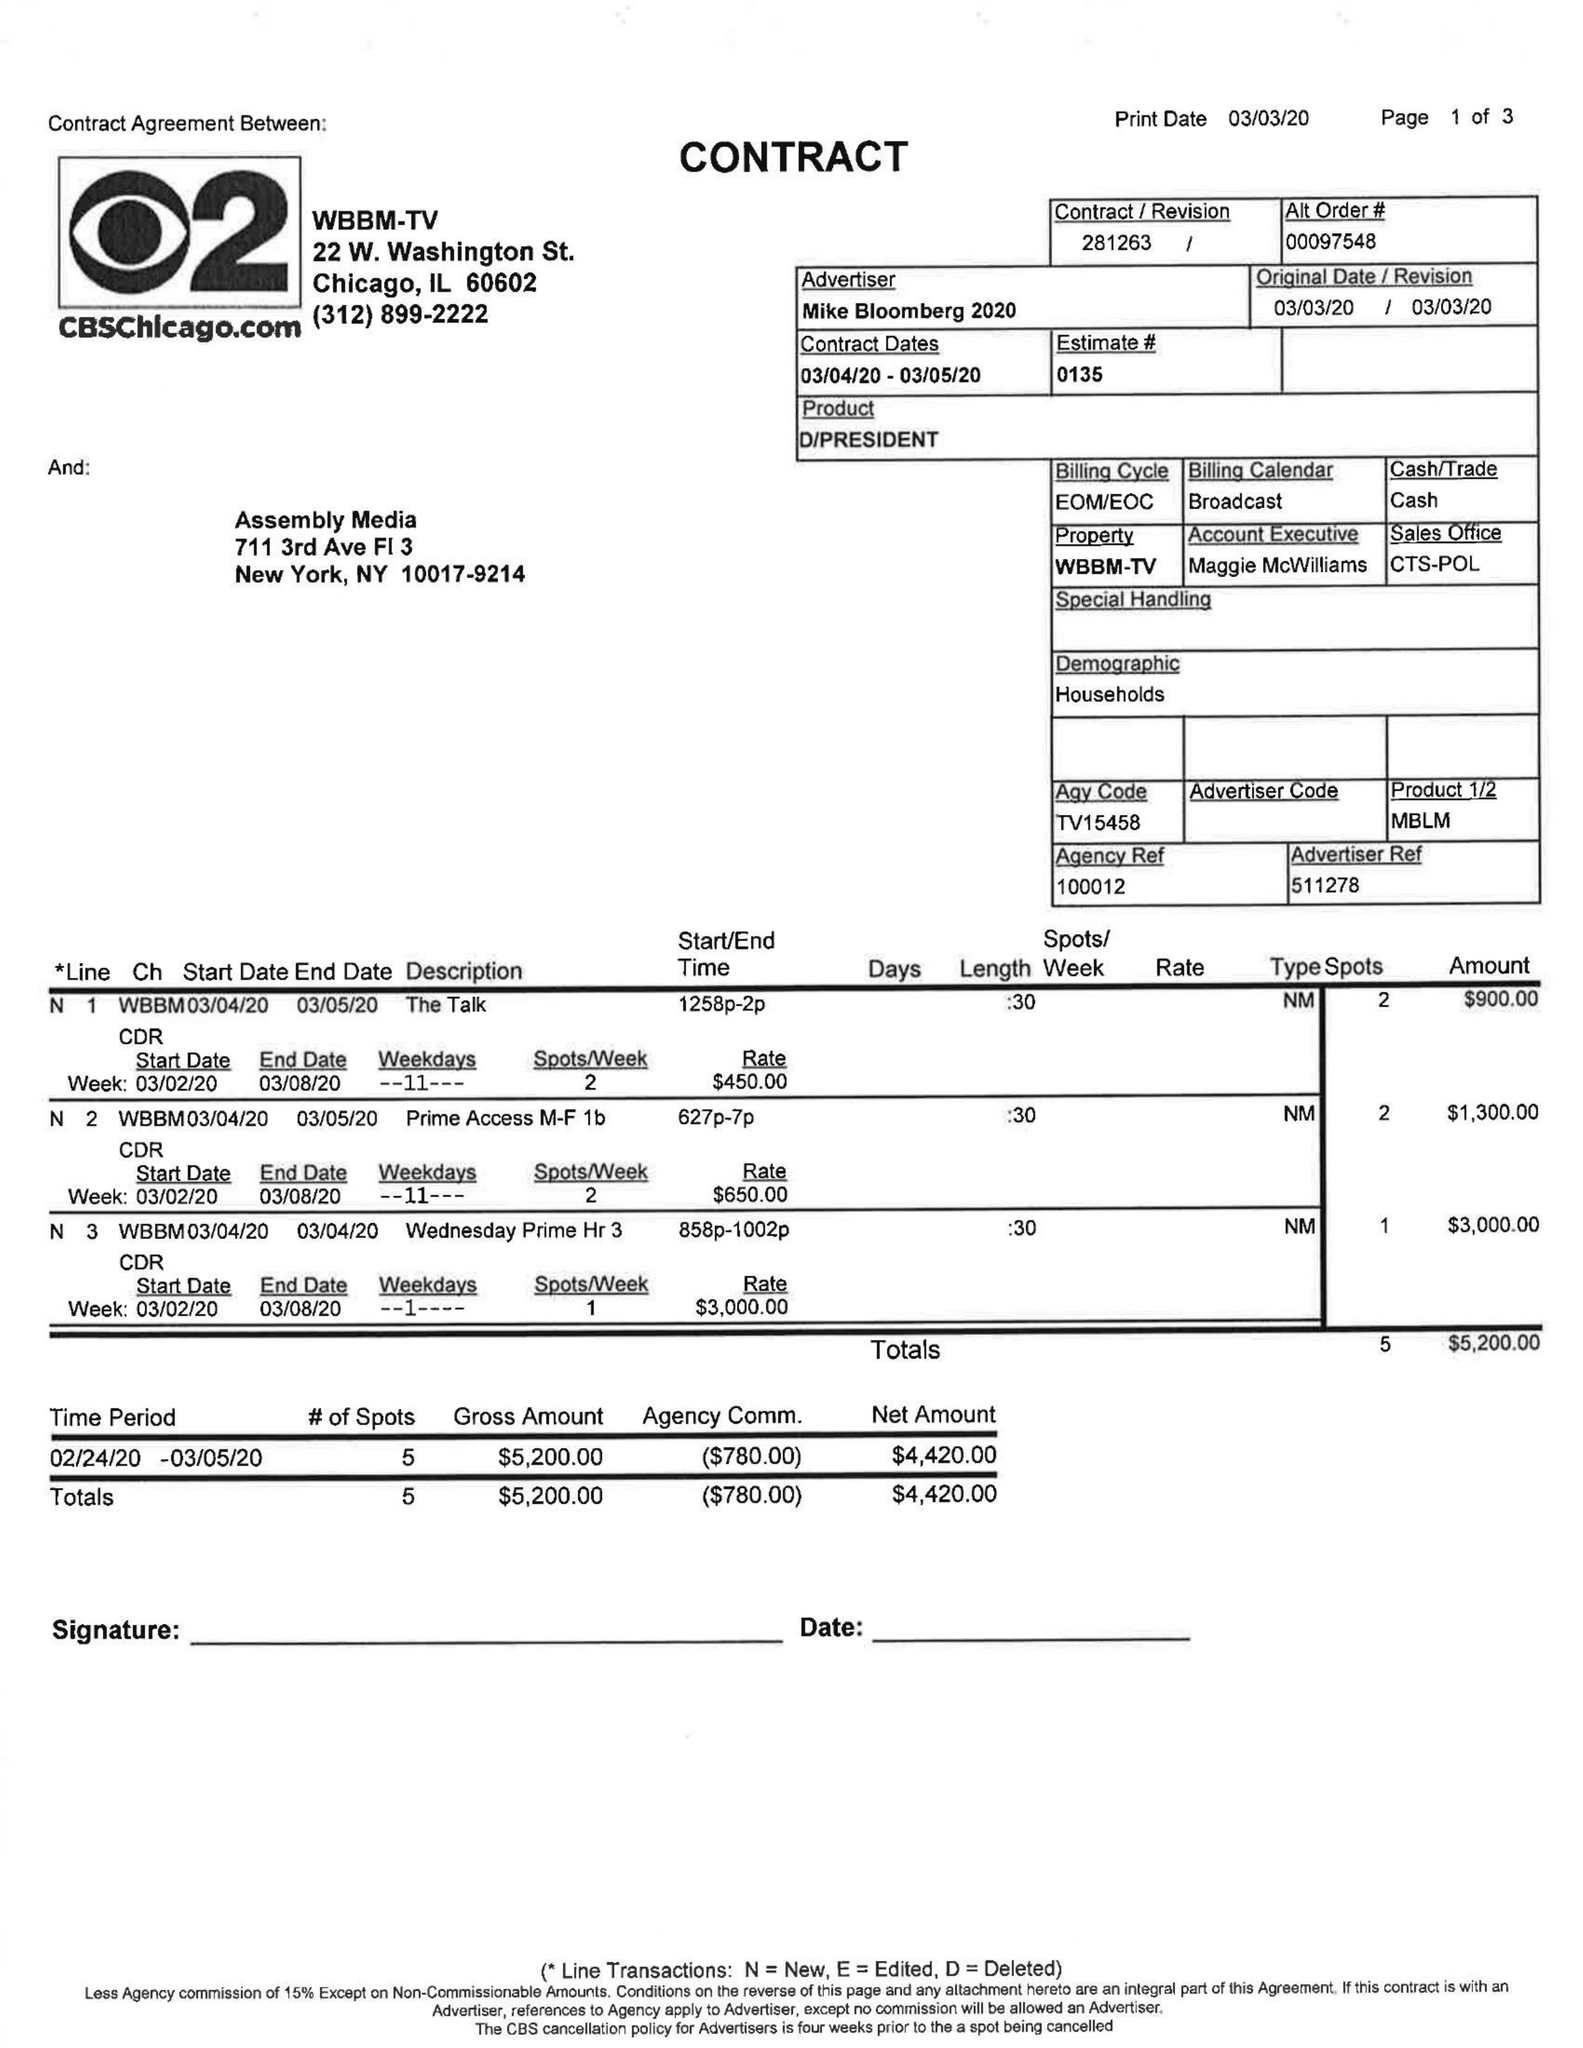What is the value for the advertiser?
Answer the question using a single word or phrase. MIKE BLOOMBERG 2020 